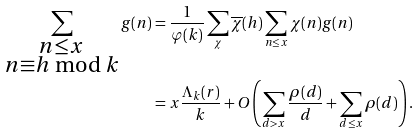Convert formula to latex. <formula><loc_0><loc_0><loc_500><loc_500>\sum _ { \substack { n \leq x \\ n \equiv h \bmod k } } g ( n ) & = \frac { 1 } { \varphi ( k ) } \sum _ { \chi } \overline { \chi } ( h ) \sum _ { n \leq x } \chi ( n ) g ( n ) \\ & = x \frac { \Lambda _ { k } ( r ) } { k } + O \left ( \sum _ { d > x } \frac { \rho ( d ) } { d } + \sum _ { d \leq x } \rho ( d ) \right ) .</formula> 